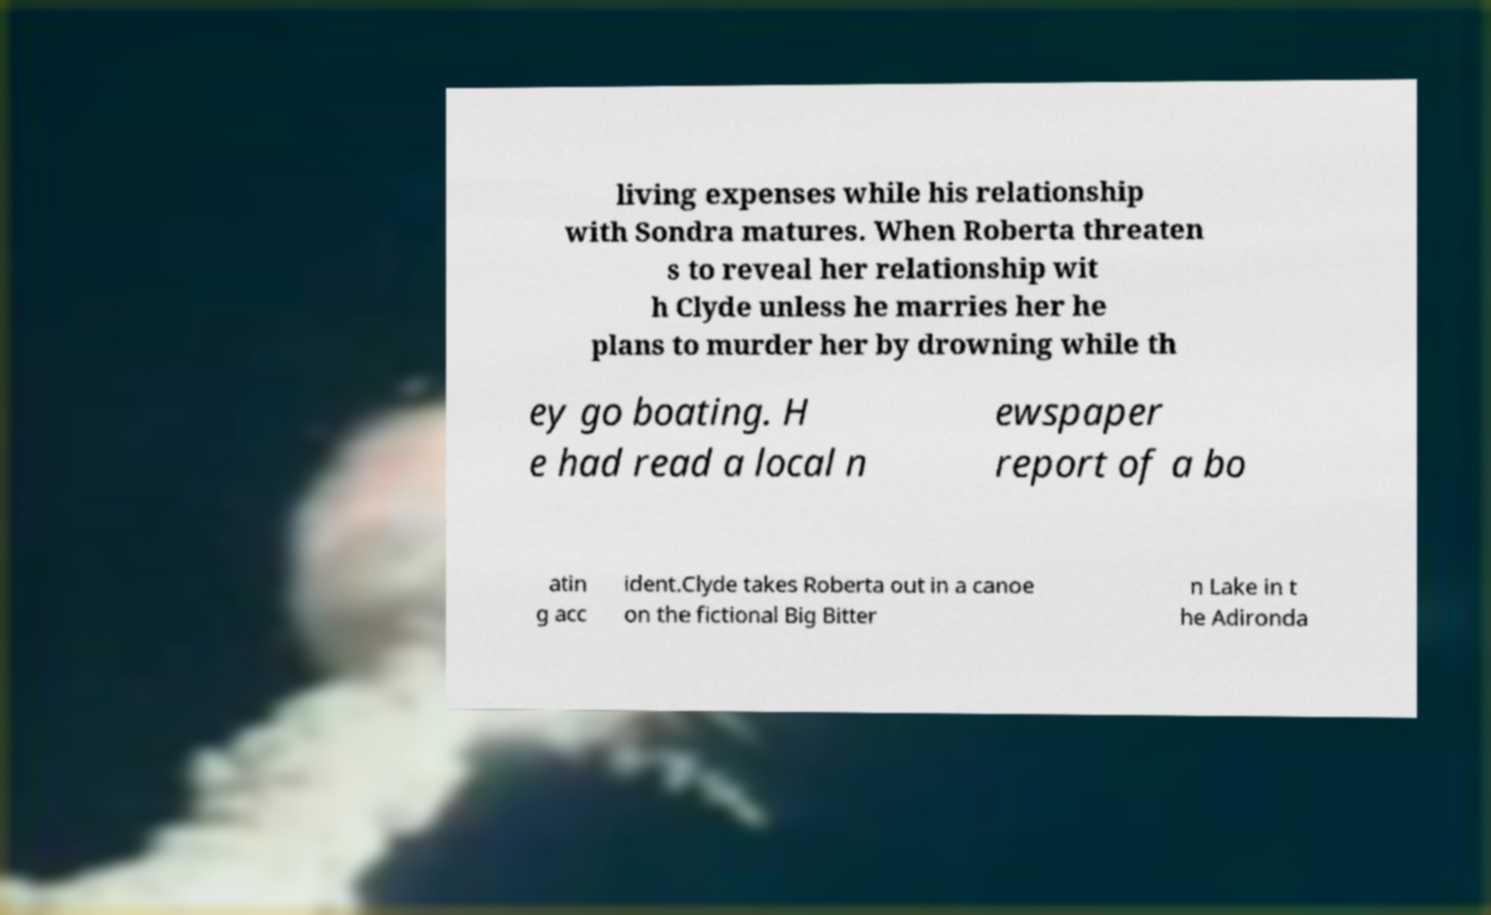Can you accurately transcribe the text from the provided image for me? living expenses while his relationship with Sondra matures. When Roberta threaten s to reveal her relationship wit h Clyde unless he marries her he plans to murder her by drowning while th ey go boating. H e had read a local n ewspaper report of a bo atin g acc ident.Clyde takes Roberta out in a canoe on the fictional Big Bitter n Lake in t he Adironda 